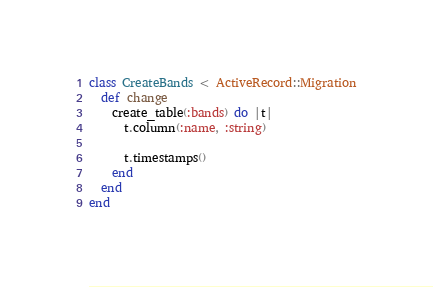Convert code to text. <code><loc_0><loc_0><loc_500><loc_500><_Ruby_>class CreateBands < ActiveRecord::Migration
  def change
    create_table(:bands) do |t|
      t.column(:name, :string)

      t.timestamps()
    end
  end
end
</code> 